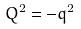Convert formula to latex. <formula><loc_0><loc_0><loc_500><loc_500>Q ^ { 2 } = - q ^ { 2 }</formula> 